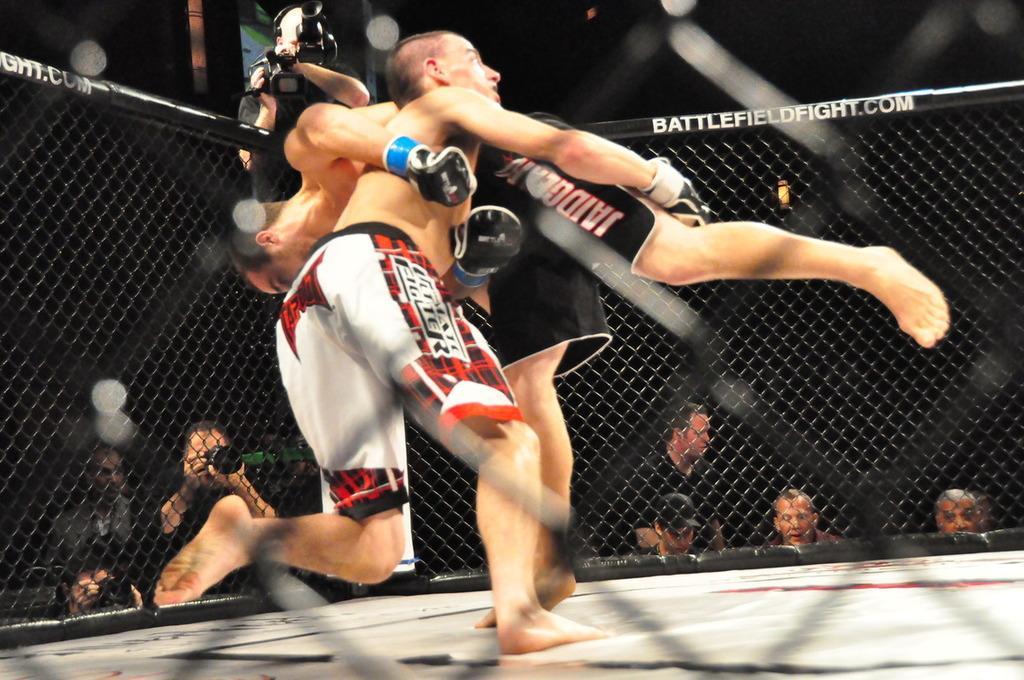Describe this image in one or two sentences. In the center of the image we can see two persons wrestling on the ground. Int he background we can see persons, camera man and fencing. 